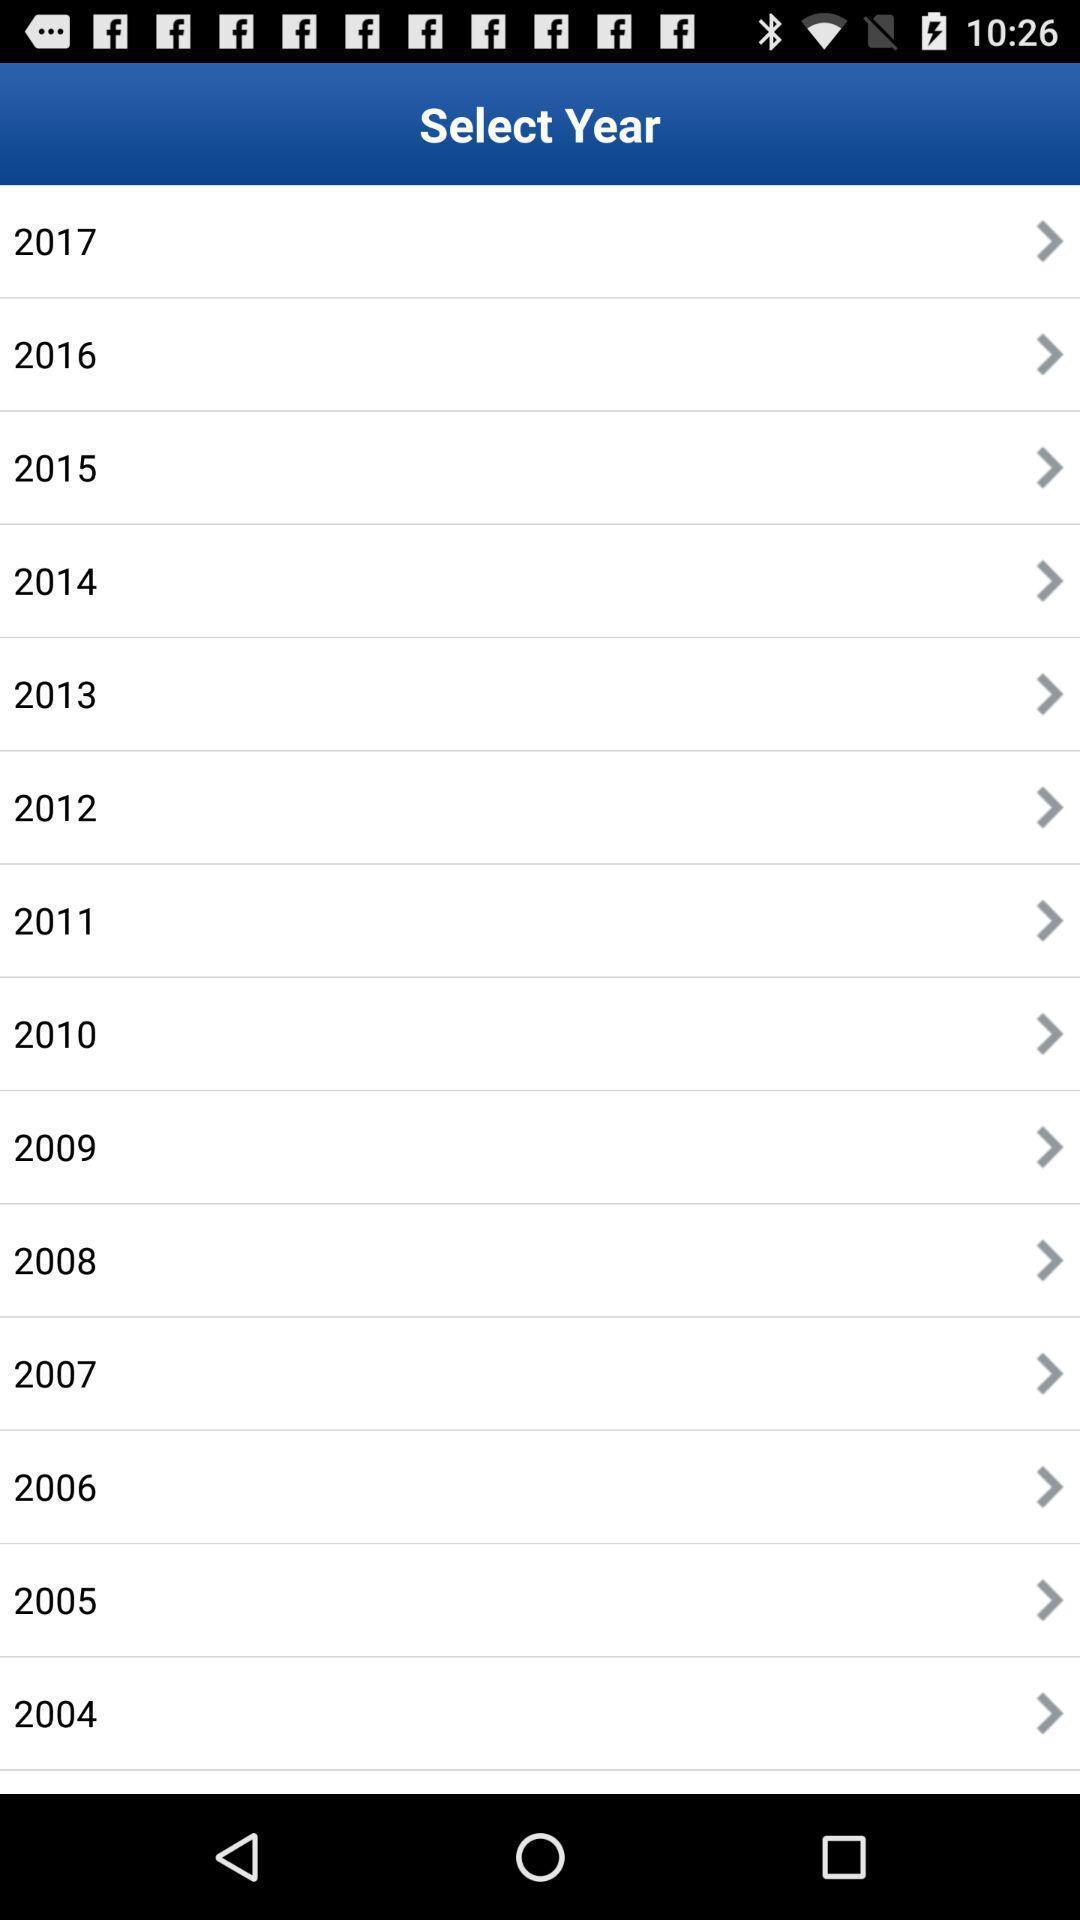Summarize the main components in this picture. Screen display list of various years. 